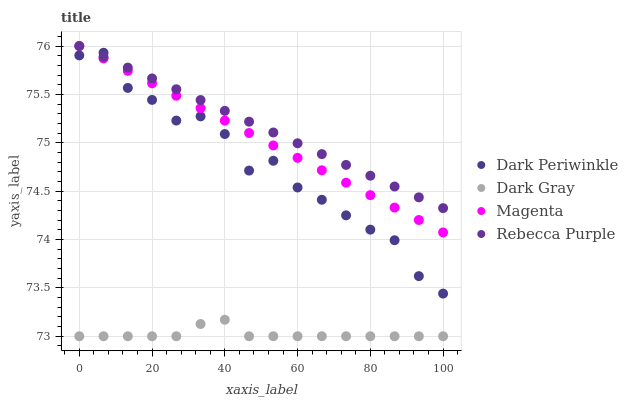Does Dark Gray have the minimum area under the curve?
Answer yes or no. Yes. Does Rebecca Purple have the maximum area under the curve?
Answer yes or no. Yes. Does Magenta have the minimum area under the curve?
Answer yes or no. No. Does Magenta have the maximum area under the curve?
Answer yes or no. No. Is Rebecca Purple the smoothest?
Answer yes or no. Yes. Is Dark Periwinkle the roughest?
Answer yes or no. Yes. Is Magenta the smoothest?
Answer yes or no. No. Is Magenta the roughest?
Answer yes or no. No. Does Dark Gray have the lowest value?
Answer yes or no. Yes. Does Magenta have the lowest value?
Answer yes or no. No. Does Rebecca Purple have the highest value?
Answer yes or no. Yes. Does Dark Periwinkle have the highest value?
Answer yes or no. No. Is Dark Gray less than Dark Periwinkle?
Answer yes or no. Yes. Is Rebecca Purple greater than Dark Gray?
Answer yes or no. Yes. Does Rebecca Purple intersect Magenta?
Answer yes or no. Yes. Is Rebecca Purple less than Magenta?
Answer yes or no. No. Is Rebecca Purple greater than Magenta?
Answer yes or no. No. Does Dark Gray intersect Dark Periwinkle?
Answer yes or no. No. 